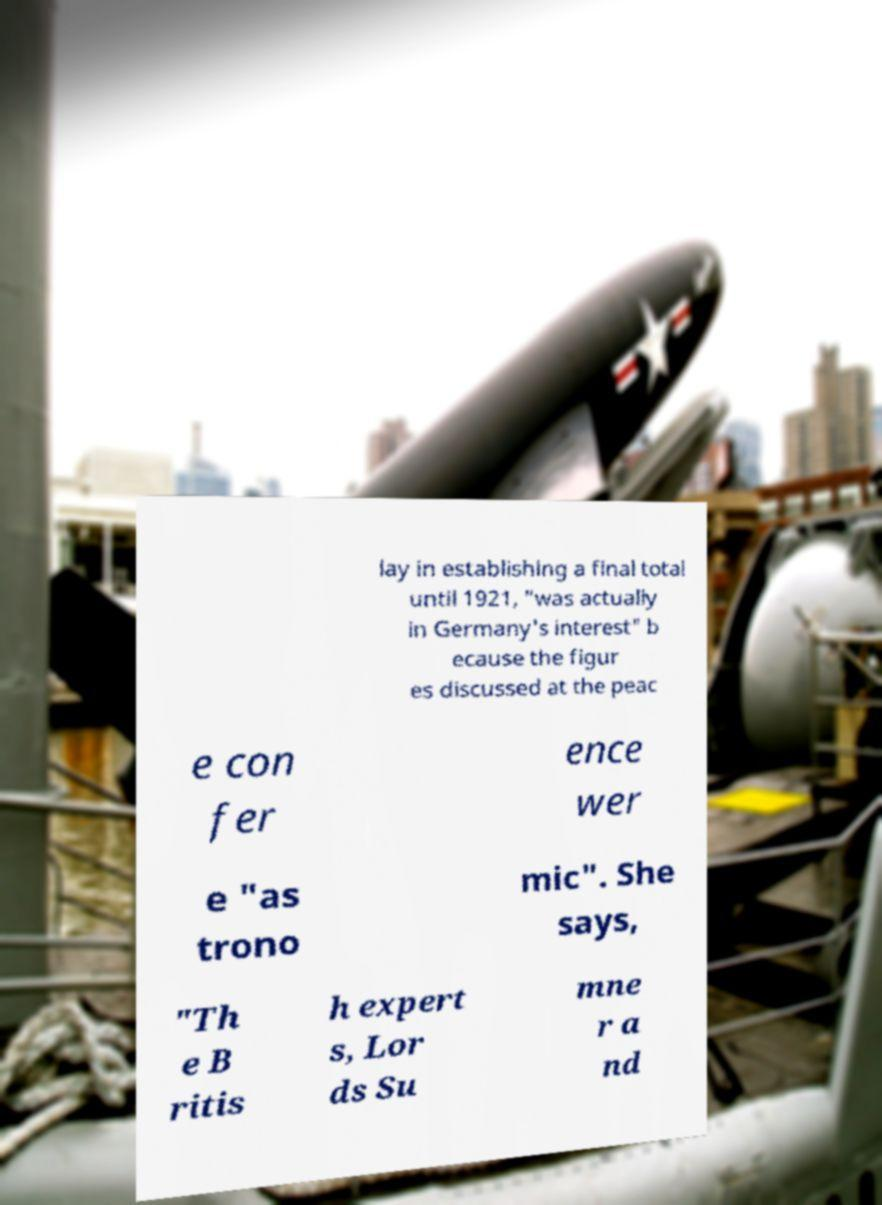Could you extract and type out the text from this image? lay in establishing a final total until 1921, "was actually in Germany's interest" b ecause the figur es discussed at the peac e con fer ence wer e "as trono mic". She says, "Th e B ritis h expert s, Lor ds Su mne r a nd 